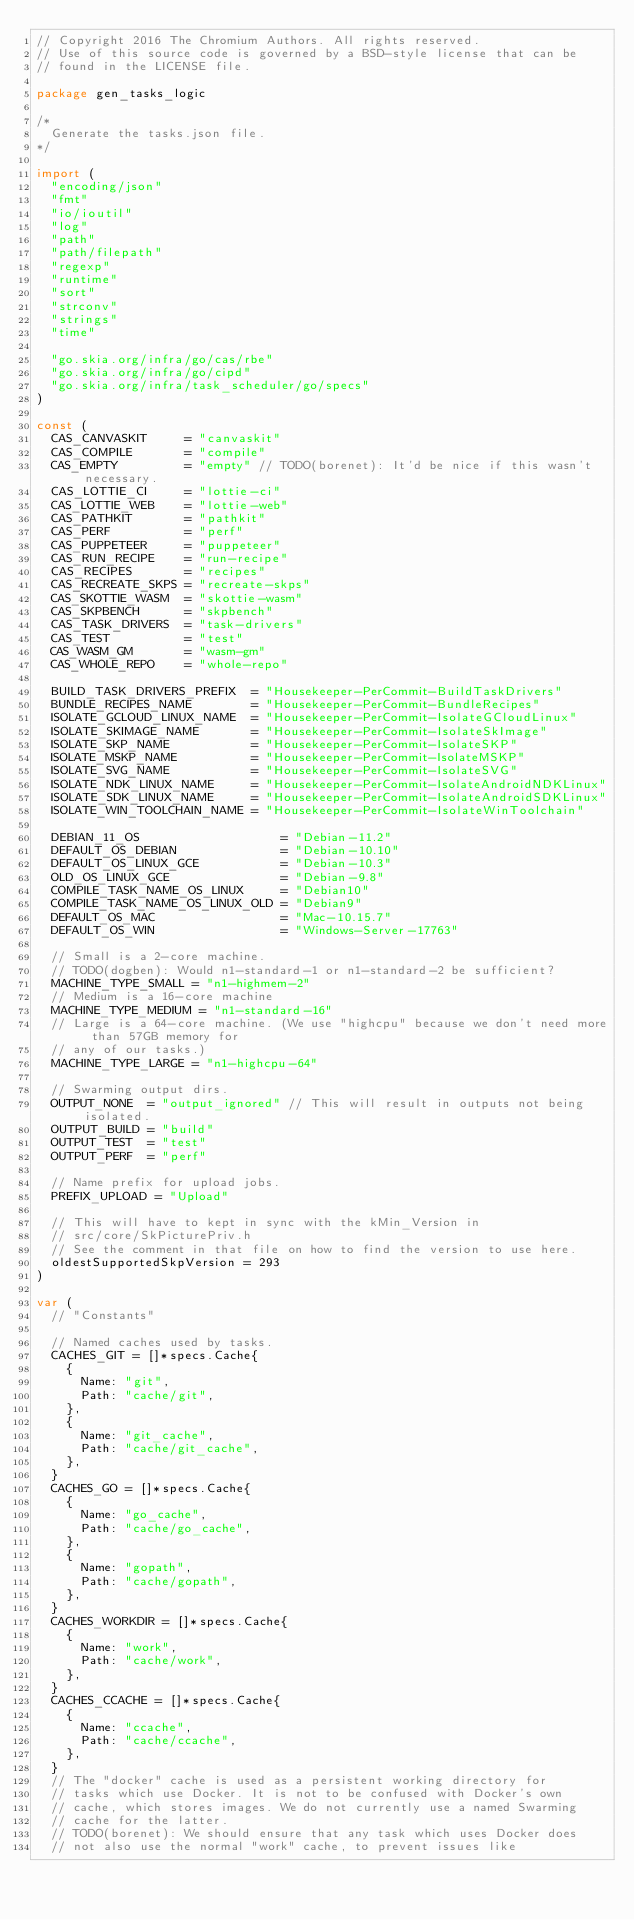<code> <loc_0><loc_0><loc_500><loc_500><_Go_>// Copyright 2016 The Chromium Authors. All rights reserved.
// Use of this source code is governed by a BSD-style license that can be
// found in the LICENSE file.

package gen_tasks_logic

/*
	Generate the tasks.json file.
*/

import (
	"encoding/json"
	"fmt"
	"io/ioutil"
	"log"
	"path"
	"path/filepath"
	"regexp"
	"runtime"
	"sort"
	"strconv"
	"strings"
	"time"

	"go.skia.org/infra/go/cas/rbe"
	"go.skia.org/infra/go/cipd"
	"go.skia.org/infra/task_scheduler/go/specs"
)

const (
	CAS_CANVASKIT     = "canvaskit"
	CAS_COMPILE       = "compile"
	CAS_EMPTY         = "empty" // TODO(borenet): It'd be nice if this wasn't necessary.
	CAS_LOTTIE_CI     = "lottie-ci"
	CAS_LOTTIE_WEB    = "lottie-web"
	CAS_PATHKIT       = "pathkit"
	CAS_PERF          = "perf"
	CAS_PUPPETEER     = "puppeteer"
	CAS_RUN_RECIPE    = "run-recipe"
	CAS_RECIPES       = "recipes"
	CAS_RECREATE_SKPS = "recreate-skps"
	CAS_SKOTTIE_WASM  = "skottie-wasm"
	CAS_SKPBENCH      = "skpbench"
	CAS_TASK_DRIVERS  = "task-drivers"
	CAS_TEST          = "test"
	CAS_WASM_GM       = "wasm-gm"
	CAS_WHOLE_REPO    = "whole-repo"

	BUILD_TASK_DRIVERS_PREFIX  = "Housekeeper-PerCommit-BuildTaskDrivers"
	BUNDLE_RECIPES_NAME        = "Housekeeper-PerCommit-BundleRecipes"
	ISOLATE_GCLOUD_LINUX_NAME  = "Housekeeper-PerCommit-IsolateGCloudLinux"
	ISOLATE_SKIMAGE_NAME       = "Housekeeper-PerCommit-IsolateSkImage"
	ISOLATE_SKP_NAME           = "Housekeeper-PerCommit-IsolateSKP"
	ISOLATE_MSKP_NAME          = "Housekeeper-PerCommit-IsolateMSKP"
	ISOLATE_SVG_NAME           = "Housekeeper-PerCommit-IsolateSVG"
	ISOLATE_NDK_LINUX_NAME     = "Housekeeper-PerCommit-IsolateAndroidNDKLinux"
	ISOLATE_SDK_LINUX_NAME     = "Housekeeper-PerCommit-IsolateAndroidSDKLinux"
	ISOLATE_WIN_TOOLCHAIN_NAME = "Housekeeper-PerCommit-IsolateWinToolchain"

	DEBIAN_11_OS                   = "Debian-11.2"
	DEFAULT_OS_DEBIAN              = "Debian-10.10"
	DEFAULT_OS_LINUX_GCE           = "Debian-10.3"
	OLD_OS_LINUX_GCE               = "Debian-9.8"
	COMPILE_TASK_NAME_OS_LINUX     = "Debian10"
	COMPILE_TASK_NAME_OS_LINUX_OLD = "Debian9"
	DEFAULT_OS_MAC                 = "Mac-10.15.7"
	DEFAULT_OS_WIN                 = "Windows-Server-17763"

	// Small is a 2-core machine.
	// TODO(dogben): Would n1-standard-1 or n1-standard-2 be sufficient?
	MACHINE_TYPE_SMALL = "n1-highmem-2"
	// Medium is a 16-core machine
	MACHINE_TYPE_MEDIUM = "n1-standard-16"
	// Large is a 64-core machine. (We use "highcpu" because we don't need more than 57GB memory for
	// any of our tasks.)
	MACHINE_TYPE_LARGE = "n1-highcpu-64"

	// Swarming output dirs.
	OUTPUT_NONE  = "output_ignored" // This will result in outputs not being isolated.
	OUTPUT_BUILD = "build"
	OUTPUT_TEST  = "test"
	OUTPUT_PERF  = "perf"

	// Name prefix for upload jobs.
	PREFIX_UPLOAD = "Upload"

	// This will have to kept in sync with the kMin_Version in
	// src/core/SkPicturePriv.h
	// See the comment in that file on how to find the version to use here.
	oldestSupportedSkpVersion = 293
)

var (
	// "Constants"

	// Named caches used by tasks.
	CACHES_GIT = []*specs.Cache{
		{
			Name: "git",
			Path: "cache/git",
		},
		{
			Name: "git_cache",
			Path: "cache/git_cache",
		},
	}
	CACHES_GO = []*specs.Cache{
		{
			Name: "go_cache",
			Path: "cache/go_cache",
		},
		{
			Name: "gopath",
			Path: "cache/gopath",
		},
	}
	CACHES_WORKDIR = []*specs.Cache{
		{
			Name: "work",
			Path: "cache/work",
		},
	}
	CACHES_CCACHE = []*specs.Cache{
		{
			Name: "ccache",
			Path: "cache/ccache",
		},
	}
	// The "docker" cache is used as a persistent working directory for
	// tasks which use Docker. It is not to be confused with Docker's own
	// cache, which stores images. We do not currently use a named Swarming
	// cache for the latter.
	// TODO(borenet): We should ensure that any task which uses Docker does
	// not also use the normal "work" cache, to prevent issues like</code> 